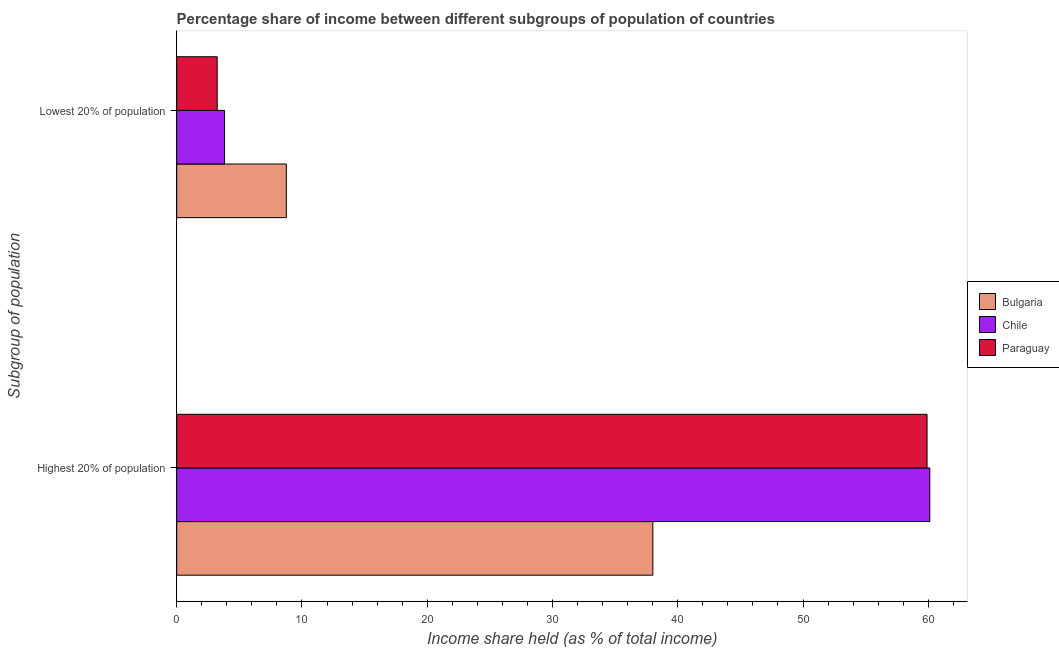Are the number of bars per tick equal to the number of legend labels?
Ensure brevity in your answer.  Yes. How many bars are there on the 2nd tick from the top?
Make the answer very short. 3. What is the label of the 2nd group of bars from the top?
Make the answer very short. Highest 20% of population. What is the income share held by highest 20% of the population in Paraguay?
Provide a short and direct response. 59.9. Across all countries, what is the maximum income share held by highest 20% of the population?
Ensure brevity in your answer.  60.12. Across all countries, what is the minimum income share held by lowest 20% of the population?
Keep it short and to the point. 3.23. In which country was the income share held by lowest 20% of the population minimum?
Offer a very short reply. Paraguay. What is the total income share held by highest 20% of the population in the graph?
Your response must be concise. 158.03. What is the difference between the income share held by lowest 20% of the population in Chile and that in Bulgaria?
Give a very brief answer. -4.93. What is the difference between the income share held by highest 20% of the population in Paraguay and the income share held by lowest 20% of the population in Chile?
Your answer should be very brief. 56.08. What is the average income share held by lowest 20% of the population per country?
Keep it short and to the point. 5.27. What is the difference between the income share held by highest 20% of the population and income share held by lowest 20% of the population in Bulgaria?
Provide a succinct answer. 29.26. What is the ratio of the income share held by lowest 20% of the population in Bulgaria to that in Chile?
Make the answer very short. 2.29. In how many countries, is the income share held by highest 20% of the population greater than the average income share held by highest 20% of the population taken over all countries?
Provide a short and direct response. 2. What does the 3rd bar from the top in Highest 20% of population represents?
Keep it short and to the point. Bulgaria. What does the 1st bar from the bottom in Lowest 20% of population represents?
Ensure brevity in your answer.  Bulgaria. Are the values on the major ticks of X-axis written in scientific E-notation?
Give a very brief answer. No. Does the graph contain any zero values?
Offer a terse response. No. Where does the legend appear in the graph?
Offer a very short reply. Center right. How many legend labels are there?
Ensure brevity in your answer.  3. What is the title of the graph?
Make the answer very short. Percentage share of income between different subgroups of population of countries. Does "Uruguay" appear as one of the legend labels in the graph?
Ensure brevity in your answer.  No. What is the label or title of the X-axis?
Ensure brevity in your answer.  Income share held (as % of total income). What is the label or title of the Y-axis?
Offer a very short reply. Subgroup of population. What is the Income share held (as % of total income) in Bulgaria in Highest 20% of population?
Make the answer very short. 38.01. What is the Income share held (as % of total income) of Chile in Highest 20% of population?
Your answer should be very brief. 60.12. What is the Income share held (as % of total income) of Paraguay in Highest 20% of population?
Offer a very short reply. 59.9. What is the Income share held (as % of total income) in Bulgaria in Lowest 20% of population?
Offer a very short reply. 8.75. What is the Income share held (as % of total income) in Chile in Lowest 20% of population?
Keep it short and to the point. 3.82. What is the Income share held (as % of total income) in Paraguay in Lowest 20% of population?
Your answer should be compact. 3.23. Across all Subgroup of population, what is the maximum Income share held (as % of total income) of Bulgaria?
Make the answer very short. 38.01. Across all Subgroup of population, what is the maximum Income share held (as % of total income) in Chile?
Ensure brevity in your answer.  60.12. Across all Subgroup of population, what is the maximum Income share held (as % of total income) of Paraguay?
Provide a short and direct response. 59.9. Across all Subgroup of population, what is the minimum Income share held (as % of total income) in Bulgaria?
Keep it short and to the point. 8.75. Across all Subgroup of population, what is the minimum Income share held (as % of total income) in Chile?
Provide a succinct answer. 3.82. Across all Subgroup of population, what is the minimum Income share held (as % of total income) of Paraguay?
Provide a short and direct response. 3.23. What is the total Income share held (as % of total income) of Bulgaria in the graph?
Your answer should be compact. 46.76. What is the total Income share held (as % of total income) of Chile in the graph?
Your answer should be very brief. 63.94. What is the total Income share held (as % of total income) in Paraguay in the graph?
Your answer should be very brief. 63.13. What is the difference between the Income share held (as % of total income) in Bulgaria in Highest 20% of population and that in Lowest 20% of population?
Keep it short and to the point. 29.26. What is the difference between the Income share held (as % of total income) of Chile in Highest 20% of population and that in Lowest 20% of population?
Make the answer very short. 56.3. What is the difference between the Income share held (as % of total income) of Paraguay in Highest 20% of population and that in Lowest 20% of population?
Your answer should be very brief. 56.67. What is the difference between the Income share held (as % of total income) of Bulgaria in Highest 20% of population and the Income share held (as % of total income) of Chile in Lowest 20% of population?
Provide a short and direct response. 34.19. What is the difference between the Income share held (as % of total income) in Bulgaria in Highest 20% of population and the Income share held (as % of total income) in Paraguay in Lowest 20% of population?
Keep it short and to the point. 34.78. What is the difference between the Income share held (as % of total income) in Chile in Highest 20% of population and the Income share held (as % of total income) in Paraguay in Lowest 20% of population?
Keep it short and to the point. 56.89. What is the average Income share held (as % of total income) in Bulgaria per Subgroup of population?
Offer a very short reply. 23.38. What is the average Income share held (as % of total income) in Chile per Subgroup of population?
Provide a succinct answer. 31.97. What is the average Income share held (as % of total income) in Paraguay per Subgroup of population?
Offer a very short reply. 31.57. What is the difference between the Income share held (as % of total income) in Bulgaria and Income share held (as % of total income) in Chile in Highest 20% of population?
Keep it short and to the point. -22.11. What is the difference between the Income share held (as % of total income) of Bulgaria and Income share held (as % of total income) of Paraguay in Highest 20% of population?
Your answer should be compact. -21.89. What is the difference between the Income share held (as % of total income) of Chile and Income share held (as % of total income) of Paraguay in Highest 20% of population?
Provide a short and direct response. 0.22. What is the difference between the Income share held (as % of total income) in Bulgaria and Income share held (as % of total income) in Chile in Lowest 20% of population?
Your answer should be compact. 4.93. What is the difference between the Income share held (as % of total income) of Bulgaria and Income share held (as % of total income) of Paraguay in Lowest 20% of population?
Give a very brief answer. 5.52. What is the difference between the Income share held (as % of total income) of Chile and Income share held (as % of total income) of Paraguay in Lowest 20% of population?
Provide a succinct answer. 0.59. What is the ratio of the Income share held (as % of total income) in Bulgaria in Highest 20% of population to that in Lowest 20% of population?
Your answer should be very brief. 4.34. What is the ratio of the Income share held (as % of total income) of Chile in Highest 20% of population to that in Lowest 20% of population?
Make the answer very short. 15.74. What is the ratio of the Income share held (as % of total income) in Paraguay in Highest 20% of population to that in Lowest 20% of population?
Ensure brevity in your answer.  18.54. What is the difference between the highest and the second highest Income share held (as % of total income) of Bulgaria?
Offer a terse response. 29.26. What is the difference between the highest and the second highest Income share held (as % of total income) of Chile?
Provide a short and direct response. 56.3. What is the difference between the highest and the second highest Income share held (as % of total income) of Paraguay?
Offer a very short reply. 56.67. What is the difference between the highest and the lowest Income share held (as % of total income) in Bulgaria?
Offer a terse response. 29.26. What is the difference between the highest and the lowest Income share held (as % of total income) in Chile?
Keep it short and to the point. 56.3. What is the difference between the highest and the lowest Income share held (as % of total income) in Paraguay?
Provide a short and direct response. 56.67. 